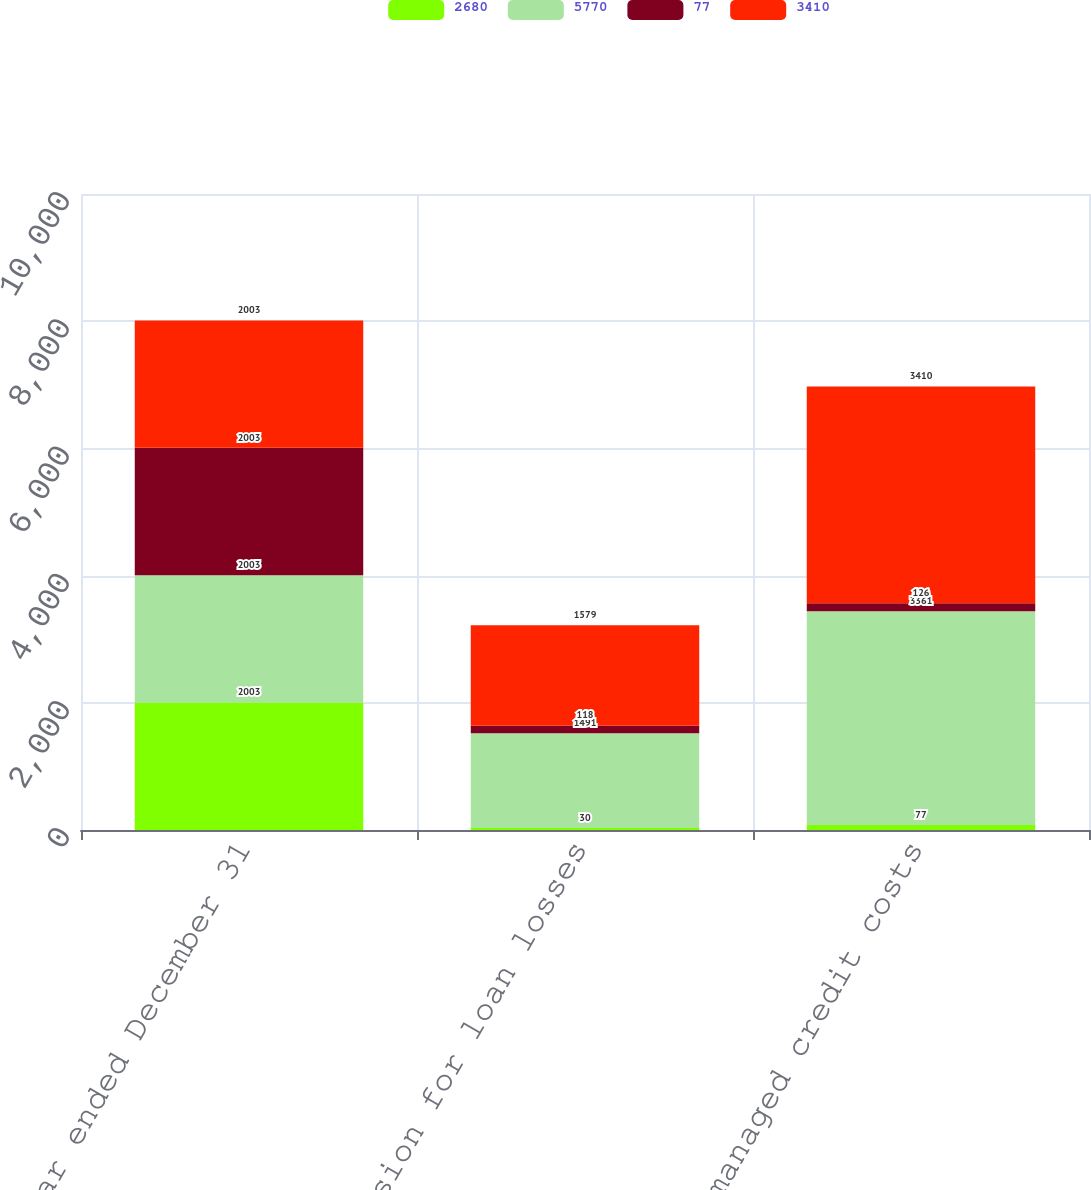<chart> <loc_0><loc_0><loc_500><loc_500><stacked_bar_chart><ecel><fcel>For the year ended December 31<fcel>Provision for loan losses<fcel>Total managed credit costs<nl><fcel>2680<fcel>2003<fcel>30<fcel>77<nl><fcel>5770<fcel>2003<fcel>1491<fcel>3361<nl><fcel>77<fcel>2003<fcel>118<fcel>126<nl><fcel>3410<fcel>2003<fcel>1579<fcel>3410<nl></chart> 